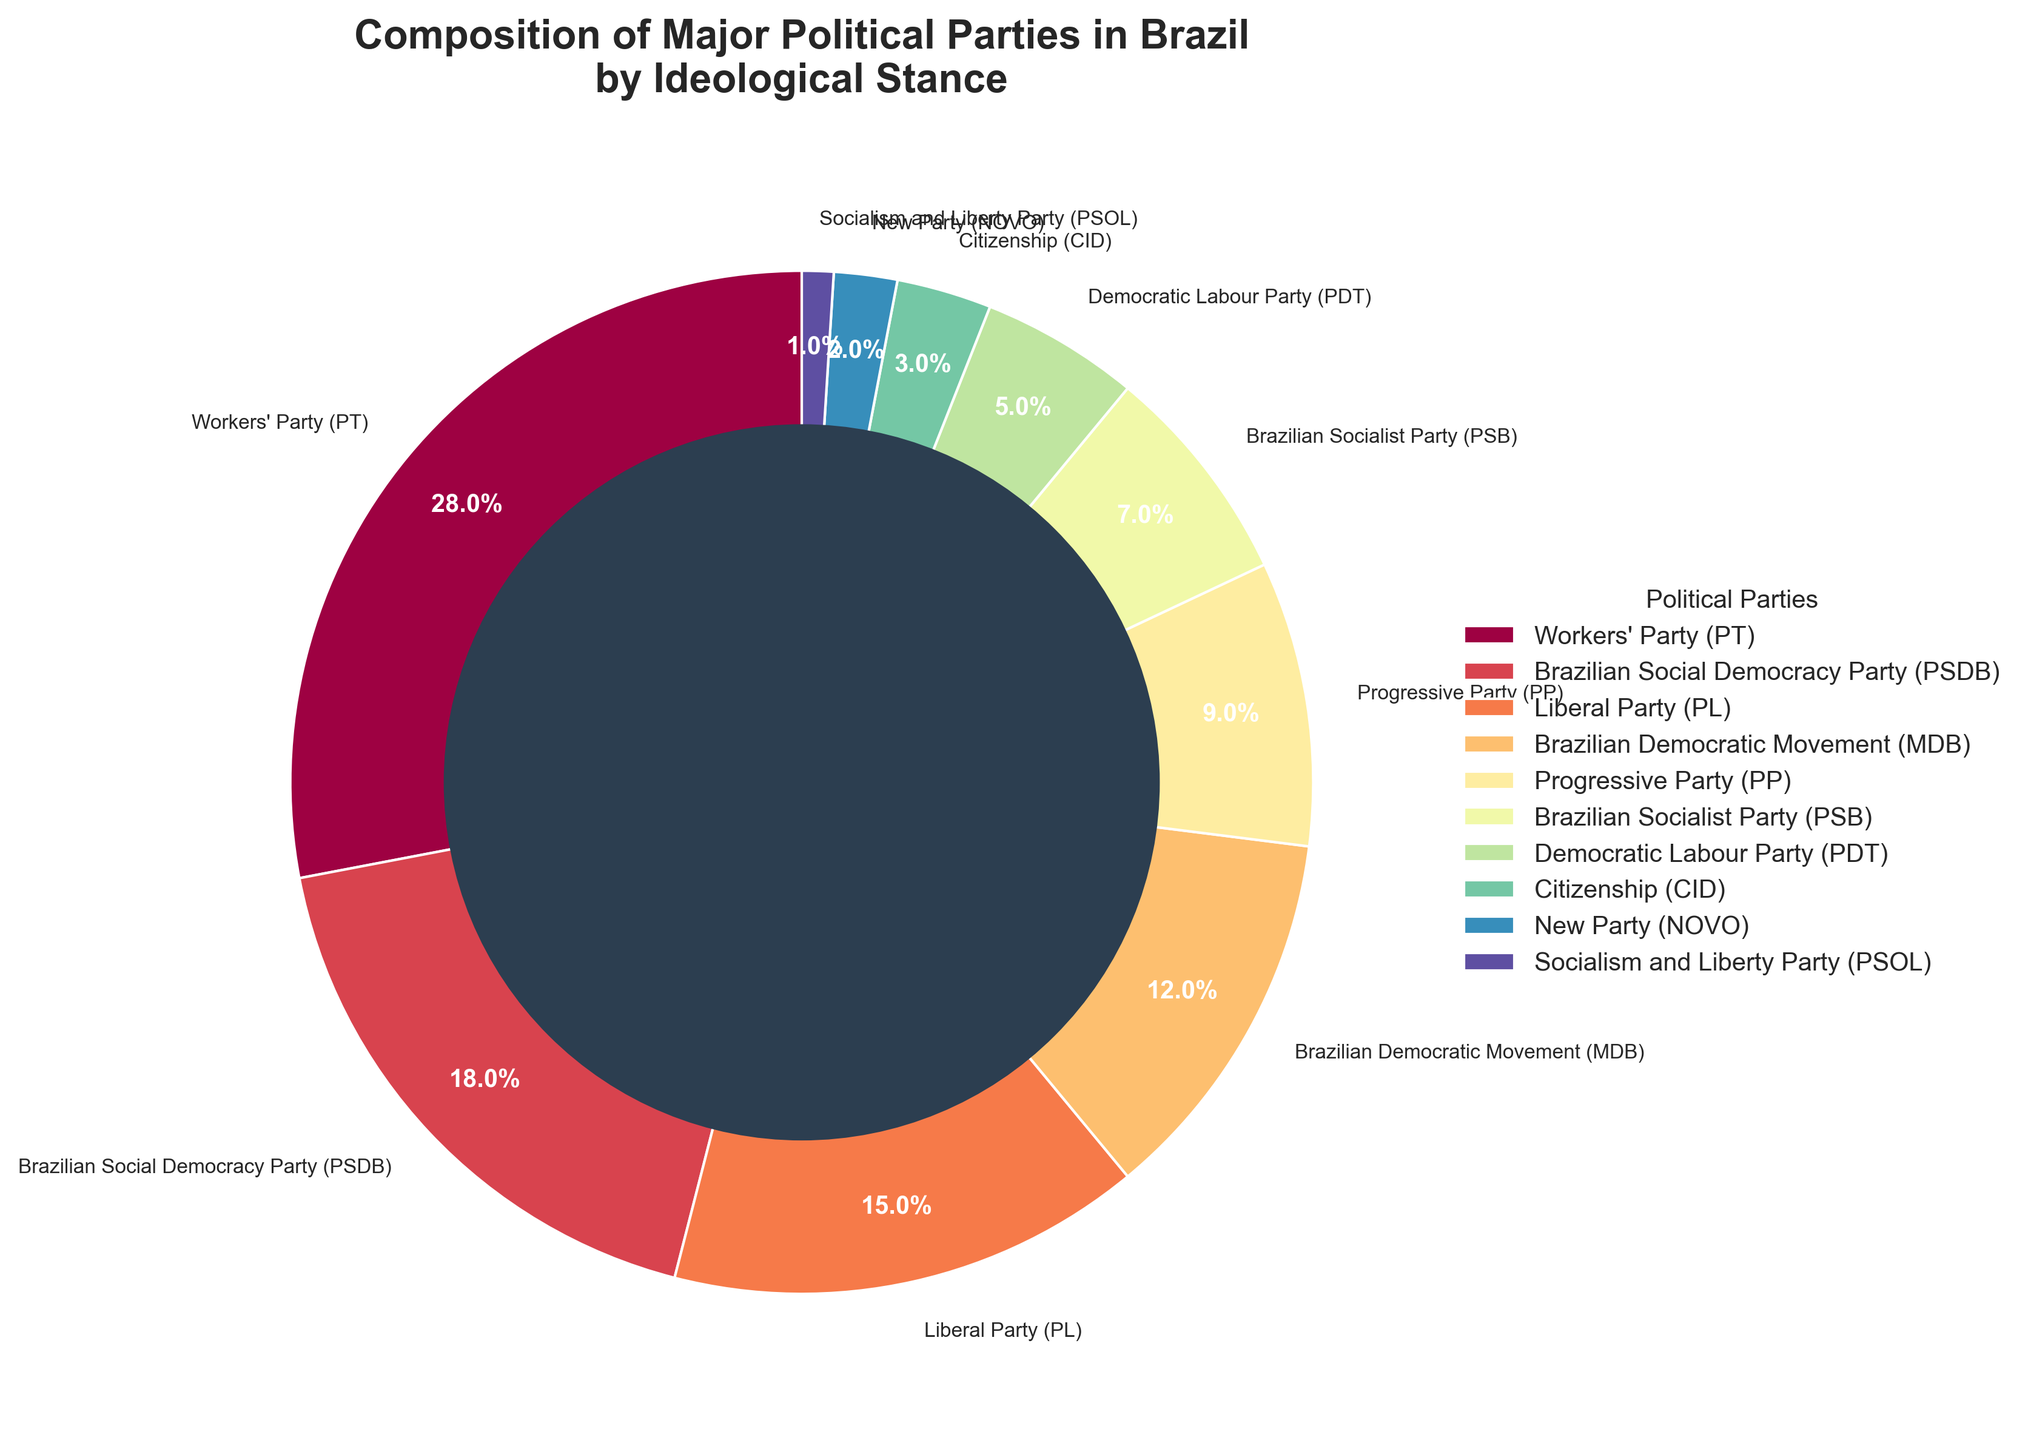What's the combined percentage of the Workers' Party (PT) and the Brazilian Social Democracy Party (PSDB)? Adding the percentages of PT (28%) and PSDB (18%): 28 + 18 = 46
Answer: 46% Which party has a higher percentage, the Brazilian Democratic Movement (MDB) or the Progressive Party (PP)? The chart shows MDB has 12% and PP has 9%. Since 12% is greater than 9%, MDB has a higher percentage.
Answer: MDB What is the difference in percentage between the party with the highest support and the party with the lowest support? The Workers' Party (PT) has the highest support with 28%, and the Socialism and Liberty Party (PSOL) has the lowest with 1%. The difference is: 28 - 1 = 27
Answer: 27% How many parties have a percentage of 10% or greater? From the chart, the parties with 10% or higher are: Workers' Party (PT) 28%, Brazilian Social Democracy Party (PSDB) 18%, Liberal Party (PL) 15%, Brazilian Democratic Movement (MDB) 12%. There are four such parties.
Answer: 4 Are there more parties with percentages less than 10% or more than 10%? There are six parties with less than 10%: PP (9%), PSB (7%), PDT (5%), Citizenship (CID) (3%), NOVO (2%), and PSOL (1%). There are four parties with more than 10%: PT (28%), PSDB (18%), PL (15%), MDB (12%). Since 6 is more than 4, there are more parties with percentages less than 10%.
Answer: Less than 10% Which party is represented by the lightest color shade in the pie chart? The code uses colors from `plt.cm.Spectral`. The wedges representing the political parties are colored according to this colormap. The lightest shade in the colormap corresponds to the midway point, which would likely be MDB at 12%.
Answer: MDB What is the average percentage of the top three political parties by support? The top three parties are: PT (28%), PSDB (18%), and PL (15%). Their average percentage is: (28 + 18 + 15) / 3 = 61 / 3 ≈ 20.33
Answer: 20.33% Which party's wedge is the thinnest, and what percentage does it represent? The thinnest wedge represents the party with the smallest percentage, which is PSOL at 1%.
Answer: PSOL, 1% Which two parties together account for the smallest combined percentage, and what is that percentage? The smallest individual percentages are PSOL (1%) and NOVO (2%). Their combined percentage is: 1 + 2 = 3
Answer: PSOL and NOVO, 3% What is the color of the party with 7% support according to the pie chart? The PSB has 7% support. The color might be identified in the visualization but generally follows the colormap defined in `plt.cm.Spectral` in the code. Since exact color names are not present in the data provided, the answer is “PSB.”
Answer: PSB 